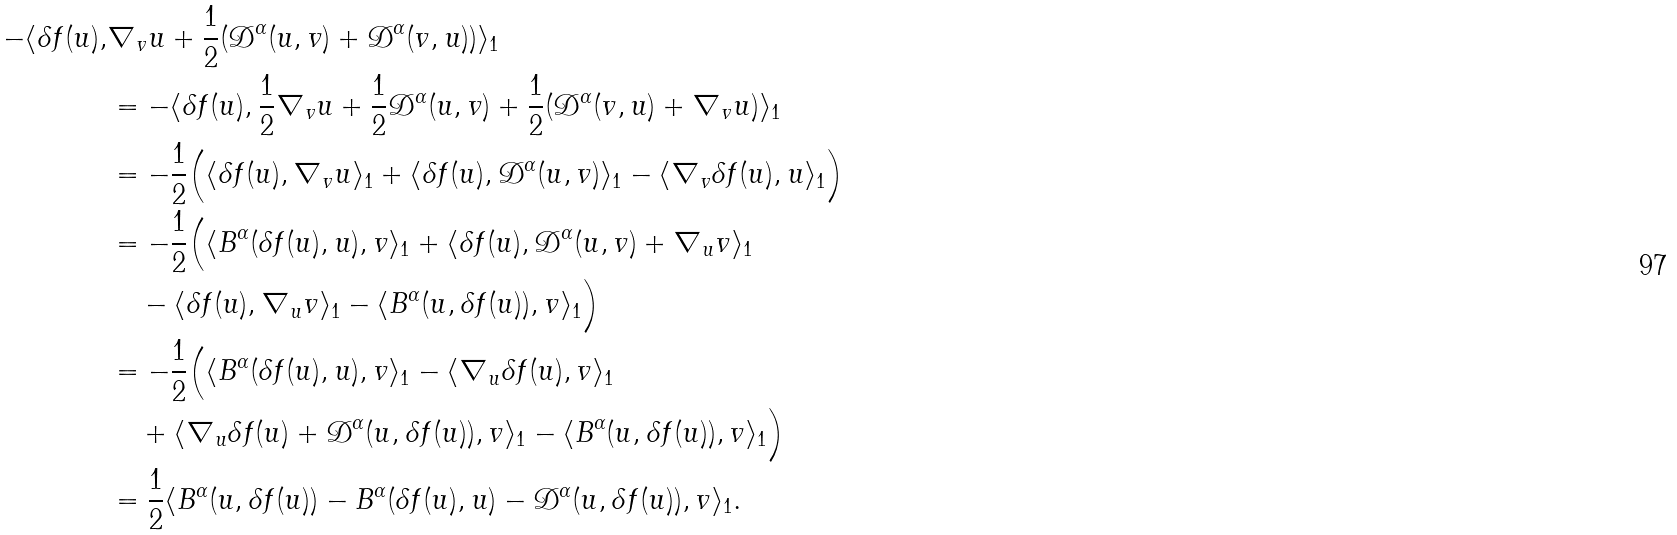Convert formula to latex. <formula><loc_0><loc_0><loc_500><loc_500>- \langle \delta f ( u ) , & \nabla _ { v } u + \frac { 1 } { 2 } ( \mathcal { D } ^ { \alpha } ( u , v ) + \mathcal { D } ^ { \alpha } ( v , u ) ) \rangle _ { 1 } \\ & = - \langle \delta f ( u ) , \frac { 1 } { 2 } \nabla _ { v } u + \frac { 1 } { 2 } \mathcal { D } ^ { \alpha } ( u , v ) + \frac { 1 } { 2 } ( \mathcal { D } ^ { \alpha } ( v , u ) + \nabla _ { v } u ) \rangle _ { 1 } \\ & = - \frac { 1 } { 2 } \Big { ( } \langle \delta f ( u ) , \nabla _ { v } u \rangle _ { 1 } + \langle \delta f ( u ) , \mathcal { D } ^ { \alpha } ( u , v ) \rangle _ { 1 } - \langle \nabla _ { v } \delta f ( u ) , u \rangle _ { 1 } \Big { ) } \\ & = - \frac { 1 } { 2 } \Big { ( } \langle B ^ { \alpha } ( \delta f ( u ) , u ) , v \rangle _ { 1 } + \langle \delta f ( u ) , \mathcal { D } ^ { \alpha } ( u , v ) + \nabla _ { u } v \rangle _ { 1 } \\ & \quad - \langle \delta f ( u ) , \nabla _ { u } v \rangle _ { 1 } - \langle B ^ { \alpha } ( u , \delta f ( u ) ) , v \rangle _ { 1 } \Big { ) } \\ & = - \frac { 1 } { 2 } \Big { ( } \langle B ^ { \alpha } ( \delta f ( u ) , u ) , v \rangle _ { 1 } - \langle \nabla _ { u } \delta f ( u ) , v \rangle _ { 1 } \\ & \quad + \langle \nabla _ { u } \delta f ( u ) + \mathcal { D } ^ { \alpha } ( u , \delta f ( u ) ) , v \rangle _ { 1 } - \langle B ^ { \alpha } ( u , \delta f ( u ) ) , v \rangle _ { 1 } \Big { ) } \\ & = \frac { 1 } { 2 } \langle B ^ { \alpha } ( u , \delta f ( u ) ) - B ^ { \alpha } ( \delta f ( u ) , u ) - \mathcal { D } ^ { \alpha } ( u , \delta f ( u ) ) , v \rangle _ { 1 } .</formula> 